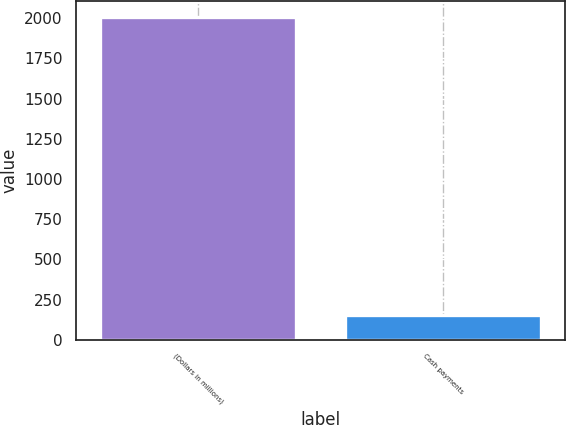Convert chart to OTSL. <chart><loc_0><loc_0><loc_500><loc_500><bar_chart><fcel>(Dollars in millions)<fcel>Cash payments<nl><fcel>2005<fcel>151<nl></chart> 